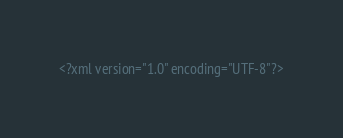Convert code to text. <code><loc_0><loc_0><loc_500><loc_500><_XML_><?xml version="1.0" encoding="UTF-8"?></code> 